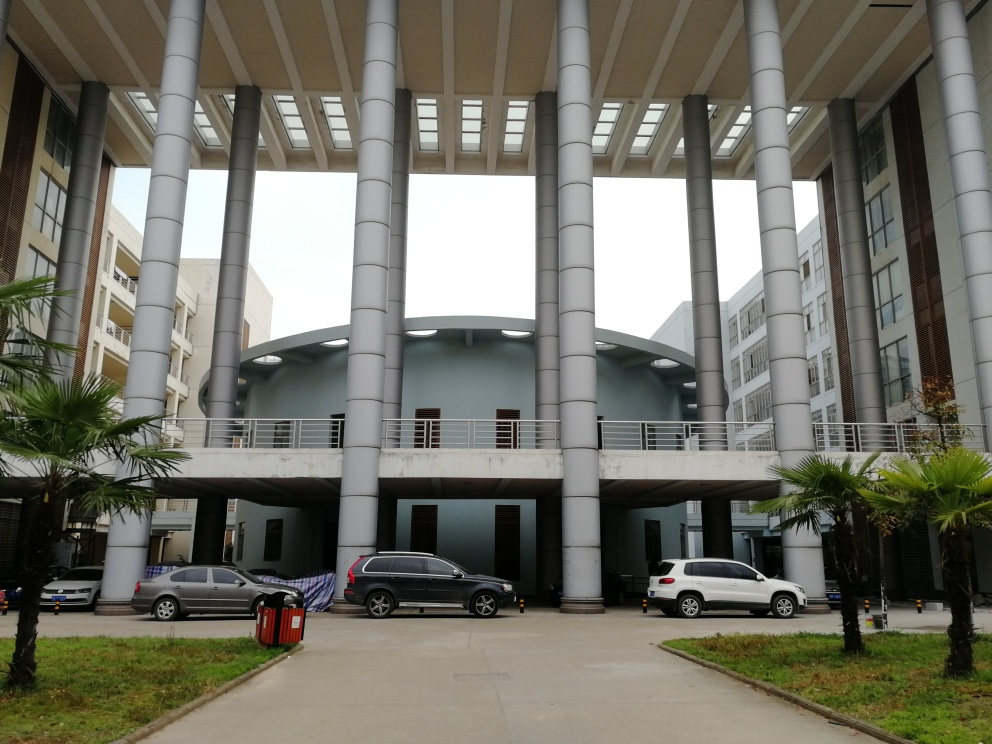Is there any underexposure in the image?
A. Yes
B. No
Answer with the option's letter from the given choices directly.
 B. 